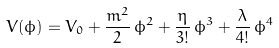<formula> <loc_0><loc_0><loc_500><loc_500>V ( \phi ) = V _ { 0 } + \frac { m ^ { 2 } } { 2 } \, \phi ^ { 2 } + \frac { \eta } { 3 ! } \, \phi ^ { 3 } + \frac { \lambda } { 4 ! } \, \phi ^ { 4 }</formula> 